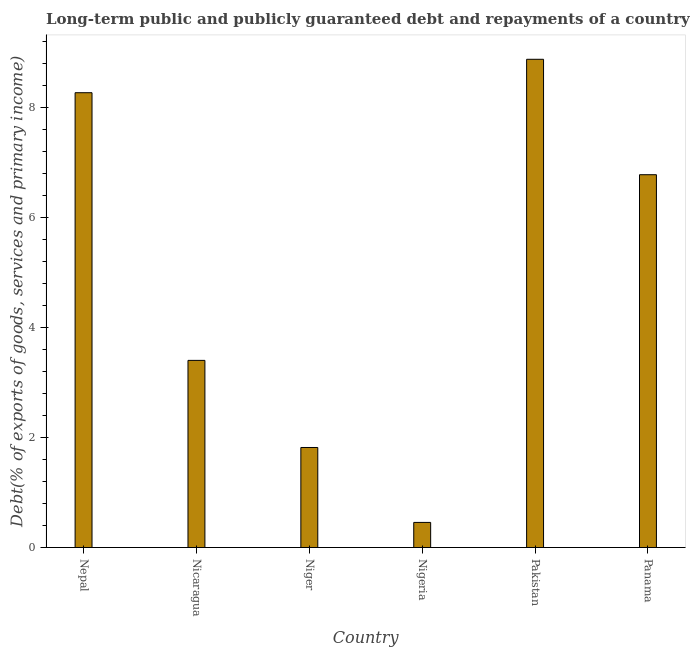Does the graph contain any zero values?
Make the answer very short. No. What is the title of the graph?
Provide a short and direct response. Long-term public and publicly guaranteed debt and repayments of a country to the IMF in 2008. What is the label or title of the Y-axis?
Your answer should be very brief. Debt(% of exports of goods, services and primary income). What is the debt service in Nicaragua?
Offer a very short reply. 3.4. Across all countries, what is the maximum debt service?
Make the answer very short. 8.88. Across all countries, what is the minimum debt service?
Provide a short and direct response. 0.46. In which country was the debt service maximum?
Ensure brevity in your answer.  Pakistan. In which country was the debt service minimum?
Provide a short and direct response. Nigeria. What is the sum of the debt service?
Your answer should be compact. 29.62. What is the difference between the debt service in Nepal and Pakistan?
Give a very brief answer. -0.61. What is the average debt service per country?
Your answer should be very brief. 4.94. What is the median debt service?
Your response must be concise. 5.09. What is the ratio of the debt service in Nepal to that in Panama?
Your response must be concise. 1.22. What is the difference between the highest and the second highest debt service?
Make the answer very short. 0.61. Is the sum of the debt service in Niger and Nigeria greater than the maximum debt service across all countries?
Your answer should be compact. No. What is the difference between the highest and the lowest debt service?
Offer a very short reply. 8.43. In how many countries, is the debt service greater than the average debt service taken over all countries?
Make the answer very short. 3. Are all the bars in the graph horizontal?
Provide a short and direct response. No. What is the Debt(% of exports of goods, services and primary income) of Nepal?
Ensure brevity in your answer.  8.27. What is the Debt(% of exports of goods, services and primary income) of Nicaragua?
Your answer should be compact. 3.4. What is the Debt(% of exports of goods, services and primary income) in Niger?
Your answer should be compact. 1.82. What is the Debt(% of exports of goods, services and primary income) in Nigeria?
Provide a short and direct response. 0.46. What is the Debt(% of exports of goods, services and primary income) of Pakistan?
Keep it short and to the point. 8.88. What is the Debt(% of exports of goods, services and primary income) in Panama?
Your answer should be very brief. 6.78. What is the difference between the Debt(% of exports of goods, services and primary income) in Nepal and Nicaragua?
Provide a short and direct response. 4.87. What is the difference between the Debt(% of exports of goods, services and primary income) in Nepal and Niger?
Keep it short and to the point. 6.45. What is the difference between the Debt(% of exports of goods, services and primary income) in Nepal and Nigeria?
Provide a succinct answer. 7.82. What is the difference between the Debt(% of exports of goods, services and primary income) in Nepal and Pakistan?
Keep it short and to the point. -0.61. What is the difference between the Debt(% of exports of goods, services and primary income) in Nepal and Panama?
Keep it short and to the point. 1.49. What is the difference between the Debt(% of exports of goods, services and primary income) in Nicaragua and Niger?
Provide a short and direct response. 1.58. What is the difference between the Debt(% of exports of goods, services and primary income) in Nicaragua and Nigeria?
Your answer should be compact. 2.95. What is the difference between the Debt(% of exports of goods, services and primary income) in Nicaragua and Pakistan?
Your answer should be very brief. -5.48. What is the difference between the Debt(% of exports of goods, services and primary income) in Nicaragua and Panama?
Your answer should be very brief. -3.38. What is the difference between the Debt(% of exports of goods, services and primary income) in Niger and Nigeria?
Keep it short and to the point. 1.36. What is the difference between the Debt(% of exports of goods, services and primary income) in Niger and Pakistan?
Offer a terse response. -7.06. What is the difference between the Debt(% of exports of goods, services and primary income) in Niger and Panama?
Ensure brevity in your answer.  -4.96. What is the difference between the Debt(% of exports of goods, services and primary income) in Nigeria and Pakistan?
Your answer should be compact. -8.43. What is the difference between the Debt(% of exports of goods, services and primary income) in Nigeria and Panama?
Ensure brevity in your answer.  -6.33. What is the difference between the Debt(% of exports of goods, services and primary income) in Pakistan and Panama?
Keep it short and to the point. 2.1. What is the ratio of the Debt(% of exports of goods, services and primary income) in Nepal to that in Nicaragua?
Make the answer very short. 2.43. What is the ratio of the Debt(% of exports of goods, services and primary income) in Nepal to that in Niger?
Provide a succinct answer. 4.55. What is the ratio of the Debt(% of exports of goods, services and primary income) in Nepal to that in Nigeria?
Ensure brevity in your answer.  18.11. What is the ratio of the Debt(% of exports of goods, services and primary income) in Nepal to that in Pakistan?
Your answer should be compact. 0.93. What is the ratio of the Debt(% of exports of goods, services and primary income) in Nepal to that in Panama?
Offer a very short reply. 1.22. What is the ratio of the Debt(% of exports of goods, services and primary income) in Nicaragua to that in Niger?
Provide a short and direct response. 1.87. What is the ratio of the Debt(% of exports of goods, services and primary income) in Nicaragua to that in Nigeria?
Make the answer very short. 7.45. What is the ratio of the Debt(% of exports of goods, services and primary income) in Nicaragua to that in Pakistan?
Provide a short and direct response. 0.38. What is the ratio of the Debt(% of exports of goods, services and primary income) in Nicaragua to that in Panama?
Offer a very short reply. 0.5. What is the ratio of the Debt(% of exports of goods, services and primary income) in Niger to that in Nigeria?
Provide a succinct answer. 3.98. What is the ratio of the Debt(% of exports of goods, services and primary income) in Niger to that in Pakistan?
Your answer should be very brief. 0.2. What is the ratio of the Debt(% of exports of goods, services and primary income) in Niger to that in Panama?
Provide a short and direct response. 0.27. What is the ratio of the Debt(% of exports of goods, services and primary income) in Nigeria to that in Pakistan?
Provide a short and direct response. 0.05. What is the ratio of the Debt(% of exports of goods, services and primary income) in Nigeria to that in Panama?
Provide a short and direct response. 0.07. What is the ratio of the Debt(% of exports of goods, services and primary income) in Pakistan to that in Panama?
Your answer should be compact. 1.31. 